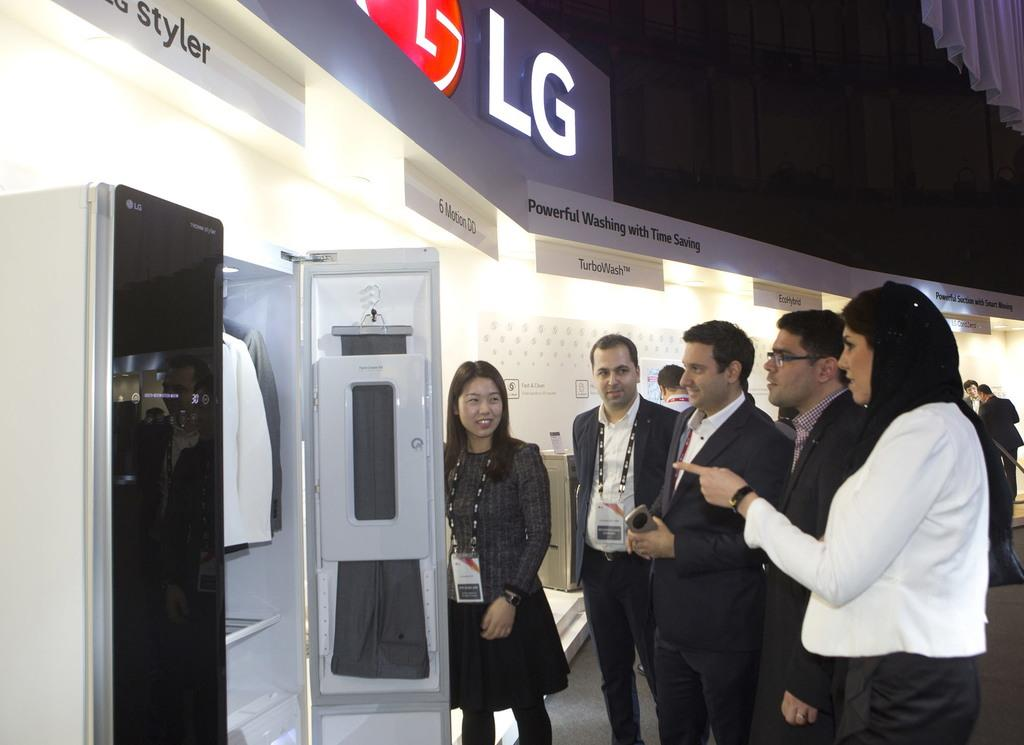<image>
Share a concise interpretation of the image provided. A sales team displays a product hat advertises powerful washing with time saving 